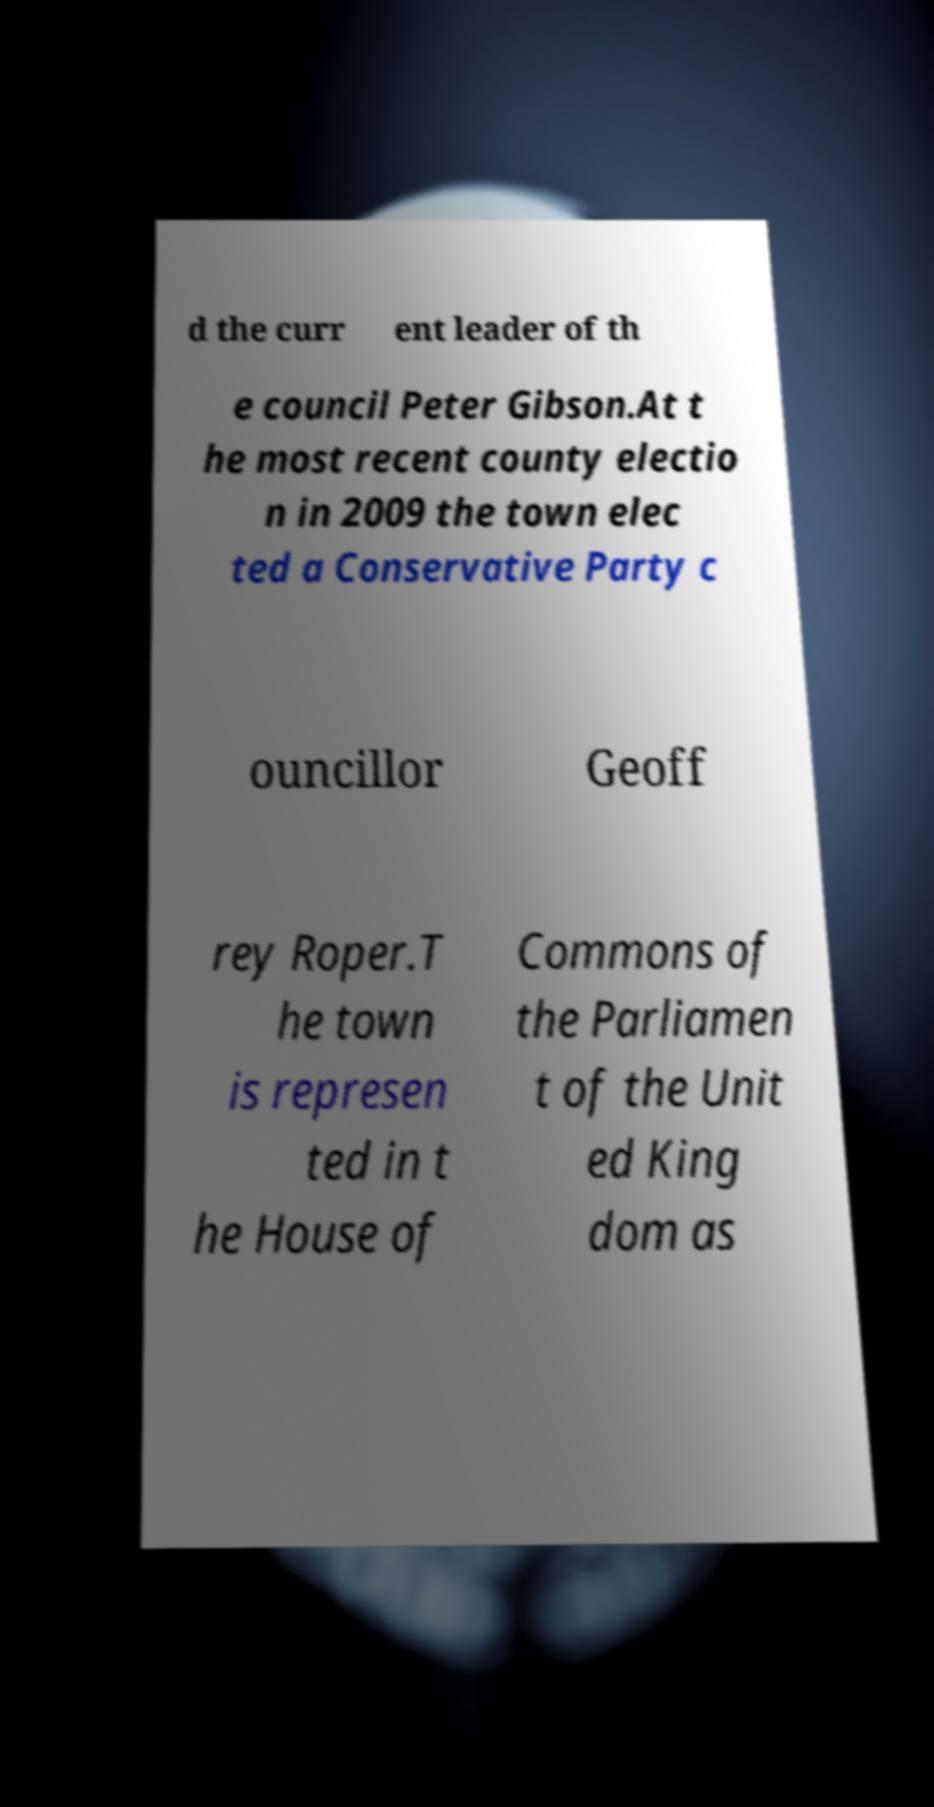Please identify and transcribe the text found in this image. d the curr ent leader of th e council Peter Gibson.At t he most recent county electio n in 2009 the town elec ted a Conservative Party c ouncillor Geoff rey Roper.T he town is represen ted in t he House of Commons of the Parliamen t of the Unit ed King dom as 